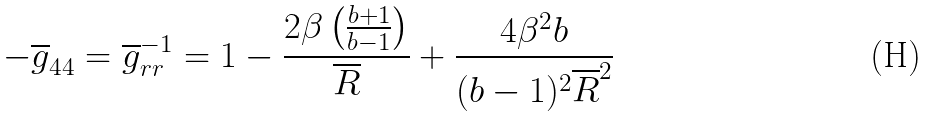Convert formula to latex. <formula><loc_0><loc_0><loc_500><loc_500>- \overline { g } _ { 4 4 } = \overline { g } _ { r r } ^ { - 1 } = 1 - \frac { 2 \beta \left ( \frac { b + 1 } { b - 1 } \right ) } { \overline { R } } + \frac { 4 \beta ^ { 2 } b } { ( b - 1 ) ^ { 2 } \overline { R } ^ { 2 } }</formula> 